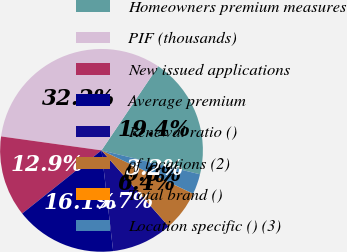<chart> <loc_0><loc_0><loc_500><loc_500><pie_chart><fcel>Homeowners premium measures<fcel>PIF (thousands)<fcel>New issued applications<fcel>Average premium<fcel>Renewal ratio ()<fcel>of locations (2)<fcel>Total brand ()<fcel>Location specific () (3)<nl><fcel>19.35%<fcel>32.25%<fcel>12.9%<fcel>16.13%<fcel>9.68%<fcel>6.45%<fcel>0.01%<fcel>3.23%<nl></chart> 